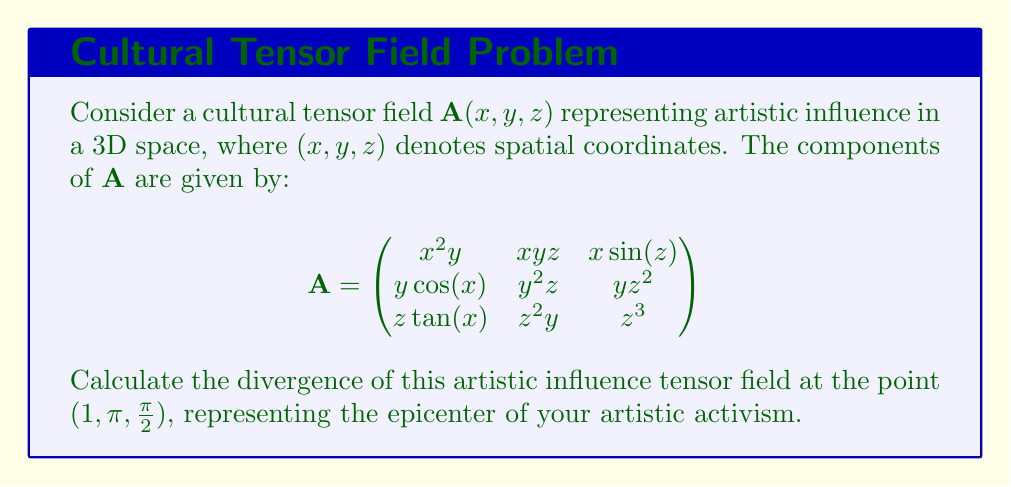Could you help me with this problem? To solve this problem, we need to follow these steps:

1) The divergence of a tensor field $\mathbf{A}$ in 3D space is given by:

   $$\text{div}(\mathbf{A}) = \frac{\partial A_{xx}}{\partial x} + \frac{\partial A_{yy}}{\partial y} + \frac{\partial A_{zz}}{\partial z}$$

   where $A_{xx}, A_{yy},$ and $A_{zz}$ are the diagonal components of the tensor.

2) From the given tensor, we have:
   $A_{xx} = x^2y$
   $A_{yy} = y^2z$
   $A_{zz} = z^3$

3) Now, let's calculate the partial derivatives:

   $$\frac{\partial A_{xx}}{\partial x} = \frac{\partial (x^2y)}{\partial x} = 2xy$$
   
   $$\frac{\partial A_{yy}}{\partial y} = \frac{\partial (y^2z)}{\partial y} = 2yz$$
   
   $$\frac{\partial A_{zz}}{\partial z} = \frac{\partial (z^3)}{\partial z} = 3z^2$$

4) Substituting these into the divergence formula:

   $$\text{div}(\mathbf{A}) = 2xy + 2yz + 3z^2$$

5) Now, we need to evaluate this at the point $(1, \pi, \frac{\pi}{2})$:

   $$\text{div}(\mathbf{A}) = 2(1)(\pi) + 2(\pi)(\frac{\pi}{2}) + 3(\frac{\pi}{2})^2$$
   
   $$= 2\pi + \pi^2 + \frac{3\pi^2}{4}$$
   
   $$= 2\pi + \frac{7\pi^2}{4}$$

This result represents the rate at which your artistic influence is spreading or concentrating at the epicenter of your activism.
Answer: $2\pi + \frac{7\pi^2}{4}$ 